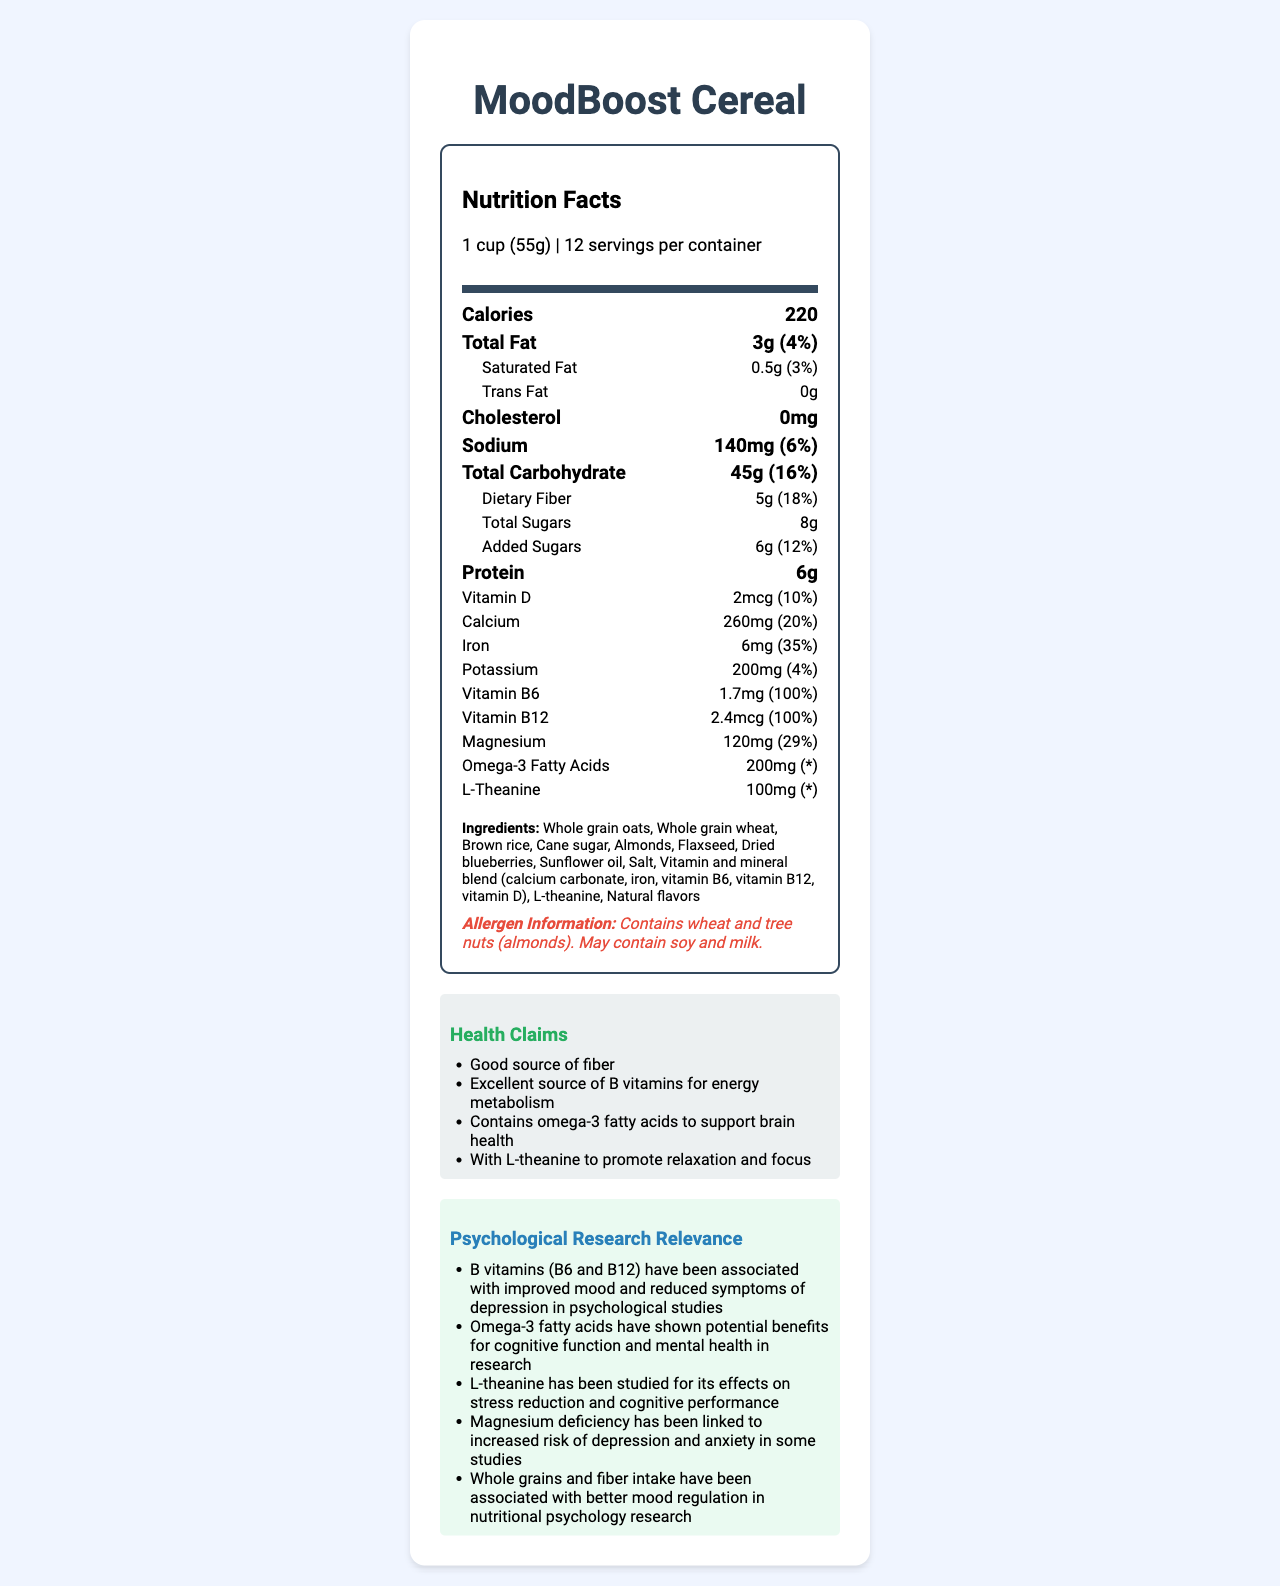what is the serving size of MoodBoost Cereal? The serving size is clearly listed under the Nutrition Facts Label as "1 cup (55g)".
Answer: 1 cup (55g) how much dietary fiber is in one serving? The Nutrition Facts Label states that there are 5 grams of dietary fiber per serving.
Answer: 5g what percentage of the daily value of vitamin B6 does one serving of the cereal provide? The Nutrition Facts Label indicates that one serving provides 100% of the daily value for vitamin B6.
Answer: 100% how many servings are there per container? The document mentions that there are 12 servings per container.
Answer: 12 which ingredient is specifically mentioned as promoting relaxation and focus? The health claims section states that L-theanine promotes relaxation and focus.
Answer: L-theanine which nutrient in the cereal could help support brain health according to the health claims? A. Iron B. Vitamin D C. Magnesium D. Omega-3 Fatty Acids The health claims section mentions that Omega-3 fatty acids support brain health.
Answer: D. Omega-3 Fatty Acids how much calcium is in one serving of the cereal? The label clearly states that there are 260 milligrams of calcium per serving.
Answer: 260mg what is the total amount of added sugars per serving? The Nutrition Facts include 6 grams of added sugars.
Answer: 6g is the cereal free from trans fat? The label indicates that the amount of trans fat per serving is 0 grams.
Answer: Yes summarize the main purpose of the document The document includes detailed nutritional facts per serving, ingredients with possible allergens, health claims, and how the cereal's nutrients are linked to mental well-being according to psychological studies.
Answer: The document presents the nutritional information, ingredients, health claims, and psychological research relevance of MoodBoost Cereal, which is advertised to improve mood and reduce stress. does the cereal contain any artificial flavors? The document only mentions "Natural flavors" but does not specify whether there are any artificial flavors or not.
Answer: Cannot be determined what is the unique substance included that is linked to stress reduction? The psychological research relevance section mentions L-theanine as a substance studied for stress reduction.
Answer: L-theanine how much magnesium is in the cereal and what percentage of the daily value does it represent? The Nutrition Facts Label indicates there is 120 mg of magnesium representing 29% of the daily value.
Answer: 120mg, 29% why is the cereal considered an excellent source of B vitamins? A. It contains high levels of Vitamin D B. It has both Vitamin B6 and B12 in optimum amounts C. It is fortified with magnesium The health claims section highlights that the cereal is an excellent source of B vitamins due to its content of both Vitamin B6 and B12.
Answer: B. It has both Vitamin B6 and B12 in optimum amounts 